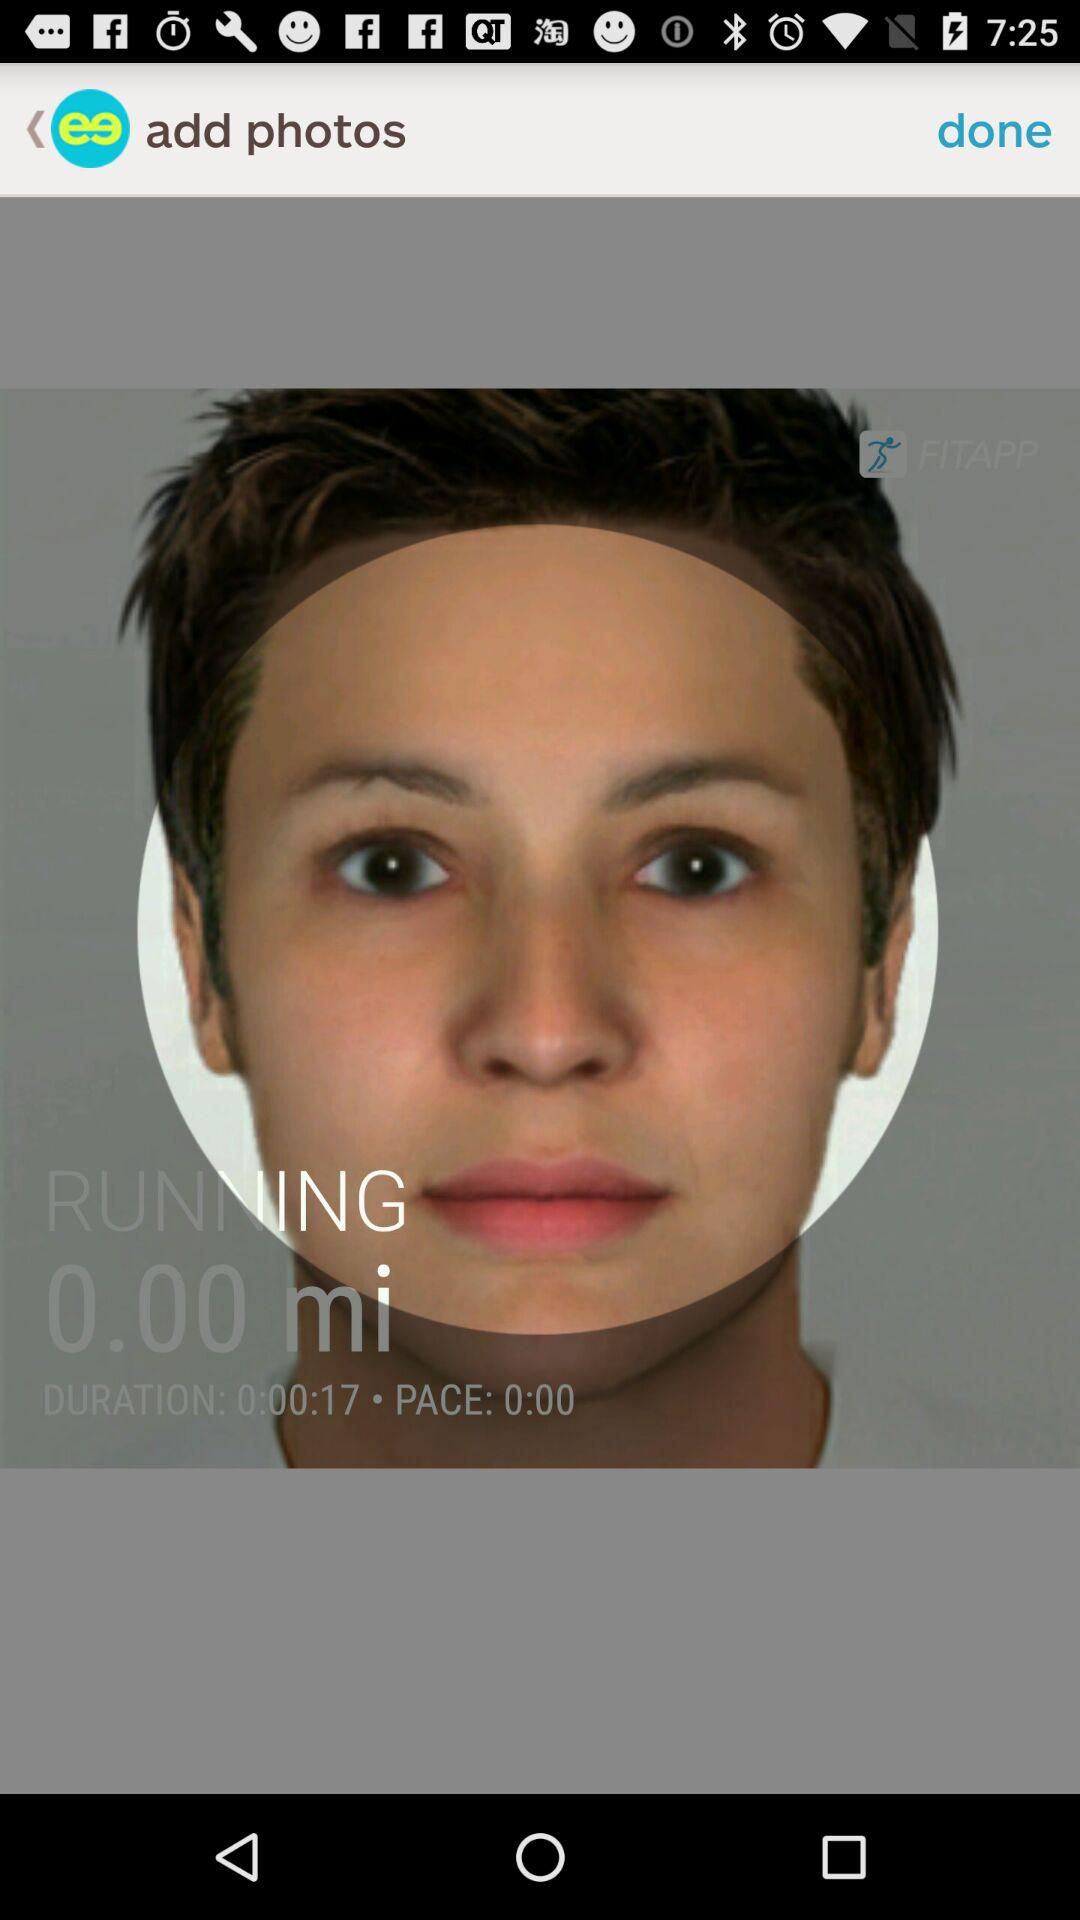How many more seconds are in the duration '0:00.17' than the pace '0.00'?
Answer the question using a single word or phrase. 0.17 